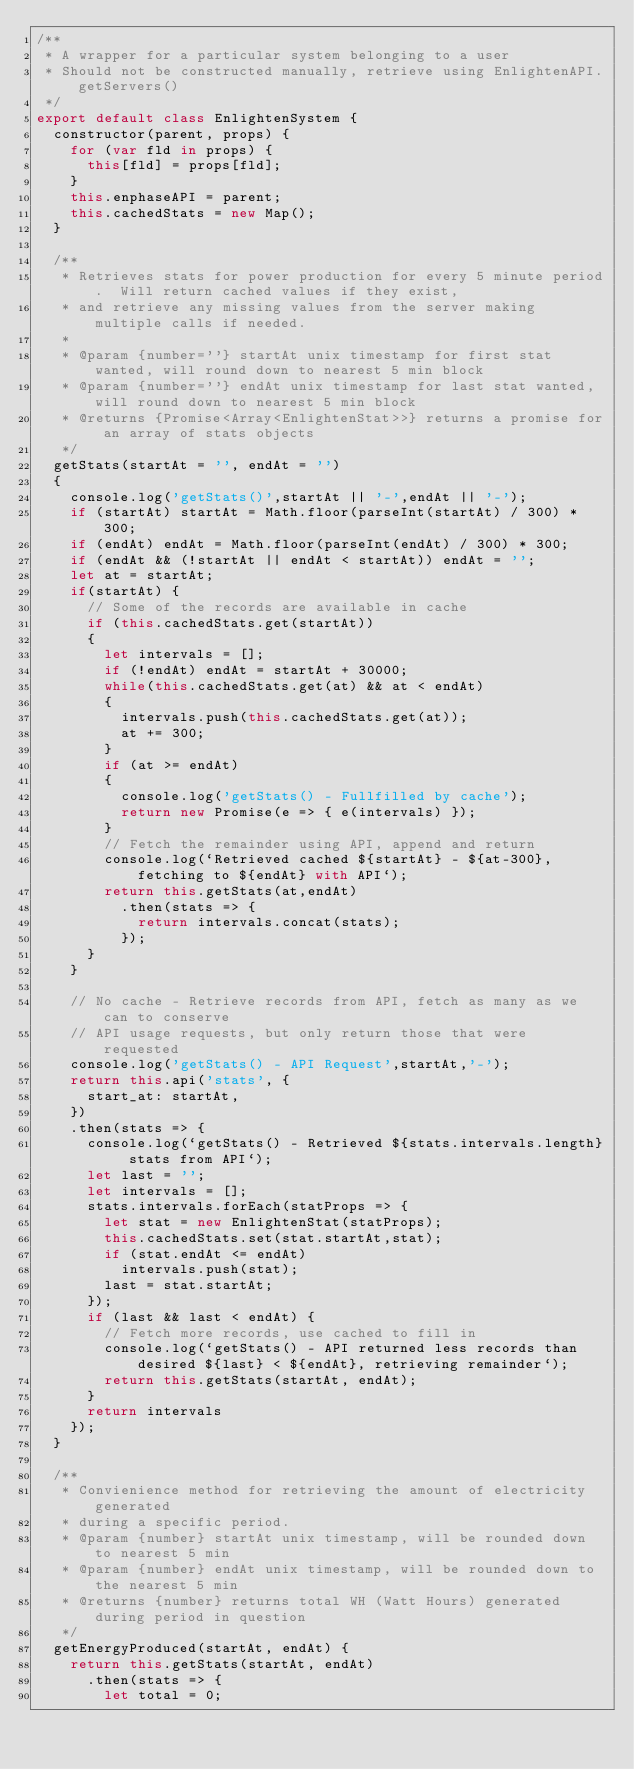<code> <loc_0><loc_0><loc_500><loc_500><_JavaScript_>/**
 * A wrapper for a particular system belonging to a user
 * Should not be constructed manually, retrieve using EnlightenAPI.getServers()
 */
export default class EnlightenSystem {
  constructor(parent, props) {
    for (var fld in props) {
      this[fld] = props[fld];
    }
    this.enphaseAPI = parent;
    this.cachedStats = new Map();
  }

  /**
   * Retrieves stats for power production for every 5 minute period.  Will return cached values if they exist,
   * and retrieve any missing values from the server making multiple calls if needed.
   * 
   * @param {number=''} startAt unix timestamp for first stat wanted, will round down to nearest 5 min block
   * @param {number=''} endAt unix timestamp for last stat wanted, will round down to nearest 5 min block
   * @returns {Promise<Array<EnlightenStat>>} returns a promise for an array of stats objects
   */
  getStats(startAt = '', endAt = '') 
  {
    console.log('getStats()',startAt || '-',endAt || '-');
    if (startAt) startAt = Math.floor(parseInt(startAt) / 300) * 300;
    if (endAt) endAt = Math.floor(parseInt(endAt) / 300) * 300;
    if (endAt && (!startAt || endAt < startAt)) endAt = '';
    let at = startAt;
    if(startAt) {
      // Some of the records are available in cache
      if (this.cachedStats.get(startAt)) 
      {
        let intervals = [];
        if (!endAt) endAt = startAt + 30000;
        while(this.cachedStats.get(at) && at < endAt)
        {
          intervals.push(this.cachedStats.get(at));
          at += 300;
        }
        if (at >= endAt) 
        {
          console.log('getStats() - Fullfilled by cache');
          return new Promise(e => { e(intervals) });
        }
        // Fetch the remainder using API, append and return
        console.log(`Retrieved cached ${startAt} - ${at-300}, fetching to ${endAt} with API`);
        return this.getStats(at,endAt)
          .then(stats => {
            return intervals.concat(stats);
          });
      }
    }

    // No cache - Retrieve records from API, fetch as many as we can to conserve
    // API usage requests, but only return those that were requested
    console.log('getStats() - API Request',startAt,'-');
    return this.api('stats', {
      start_at: startAt,
    })
    .then(stats => {
      console.log(`getStats() - Retrieved ${stats.intervals.length} stats from API`);
      let last = '';
      let intervals = [];
      stats.intervals.forEach(statProps => {
        let stat = new EnlightenStat(statProps);
        this.cachedStats.set(stat.startAt,stat);
        if (stat.endAt <= endAt)
          intervals.push(stat);
        last = stat.startAt;
      });
      if (last && last < endAt) {
        // Fetch more records, use cached to fill in
        console.log(`getStats() - API returned less records than desired ${last} < ${endAt}, retrieving remainder`);
        return this.getStats(startAt, endAt);
      }
      return intervals
    });
  }

  /**
   * Convienience method for retrieving the amount of electricity generated
   * during a specific period.
   * @param {number} startAt unix timestamp, will be rounded down to nearest 5 min
   * @param {number} endAt unix timestamp, will be rounded down to the nearest 5 min
   * @returns {number} returns total WH (Watt Hours) generated during period in question
   */
  getEnergyProduced(startAt, endAt) {
    return this.getStats(startAt, endAt)
      .then(stats => {
        let total = 0;</code> 